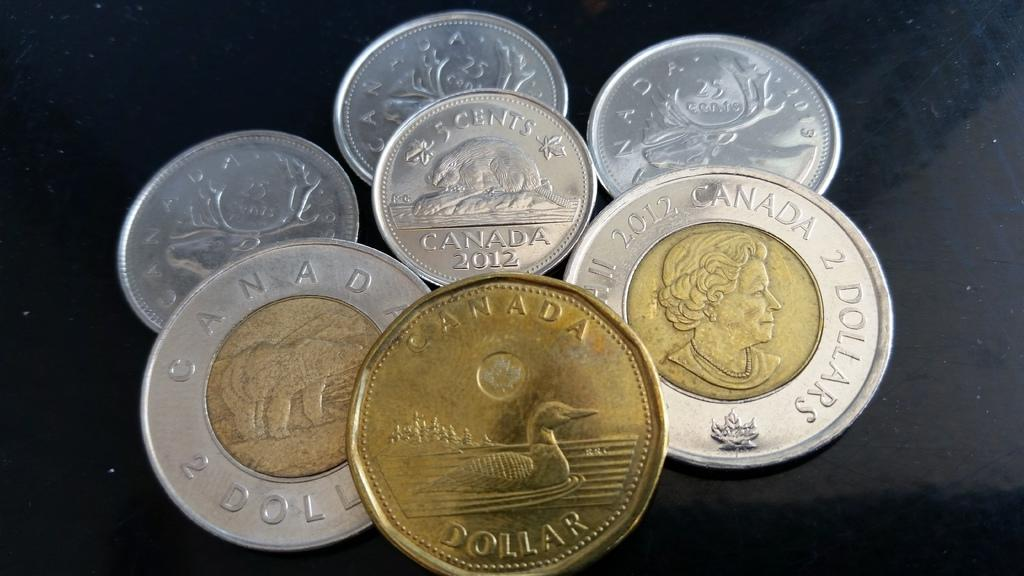Provide a one-sentence caption for the provided image. A variety of Canadian coins piled on top of each other. 